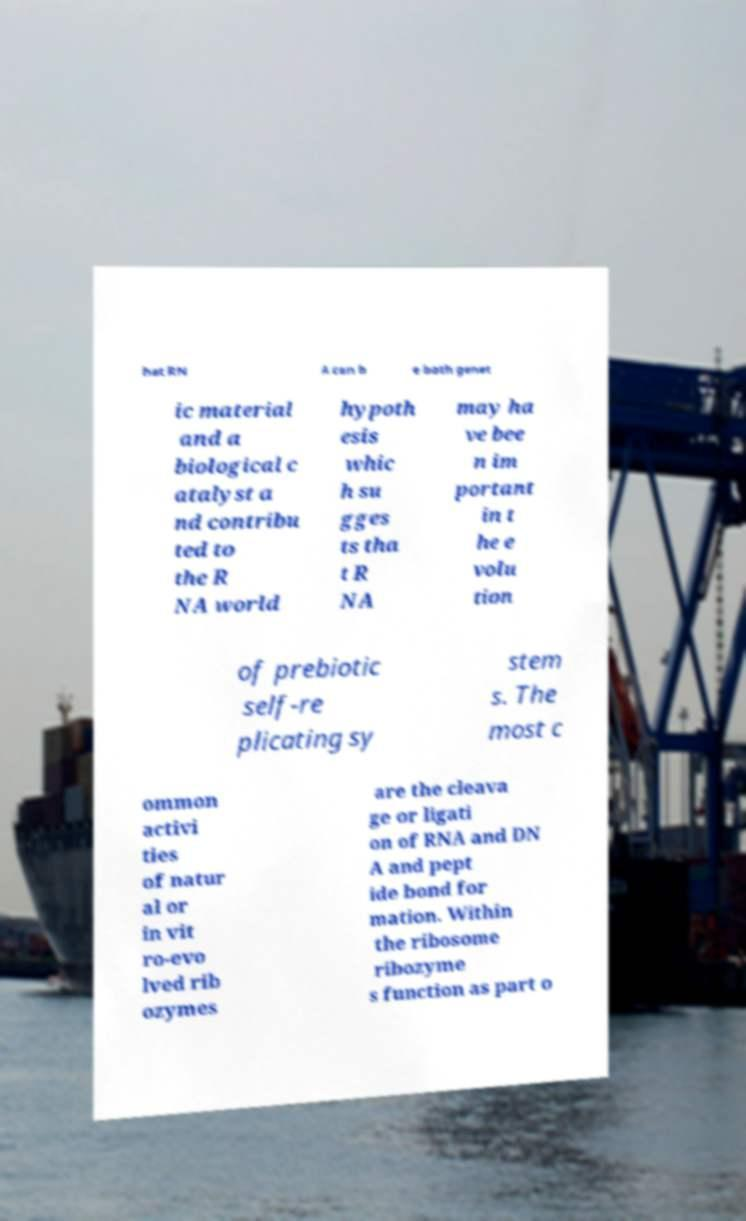Please read and relay the text visible in this image. What does it say? hat RN A can b e both genet ic material and a biological c atalyst a nd contribu ted to the R NA world hypoth esis whic h su gges ts tha t R NA may ha ve bee n im portant in t he e volu tion of prebiotic self-re plicating sy stem s. The most c ommon activi ties of natur al or in vit ro-evo lved rib ozymes are the cleava ge or ligati on of RNA and DN A and pept ide bond for mation. Within the ribosome ribozyme s function as part o 